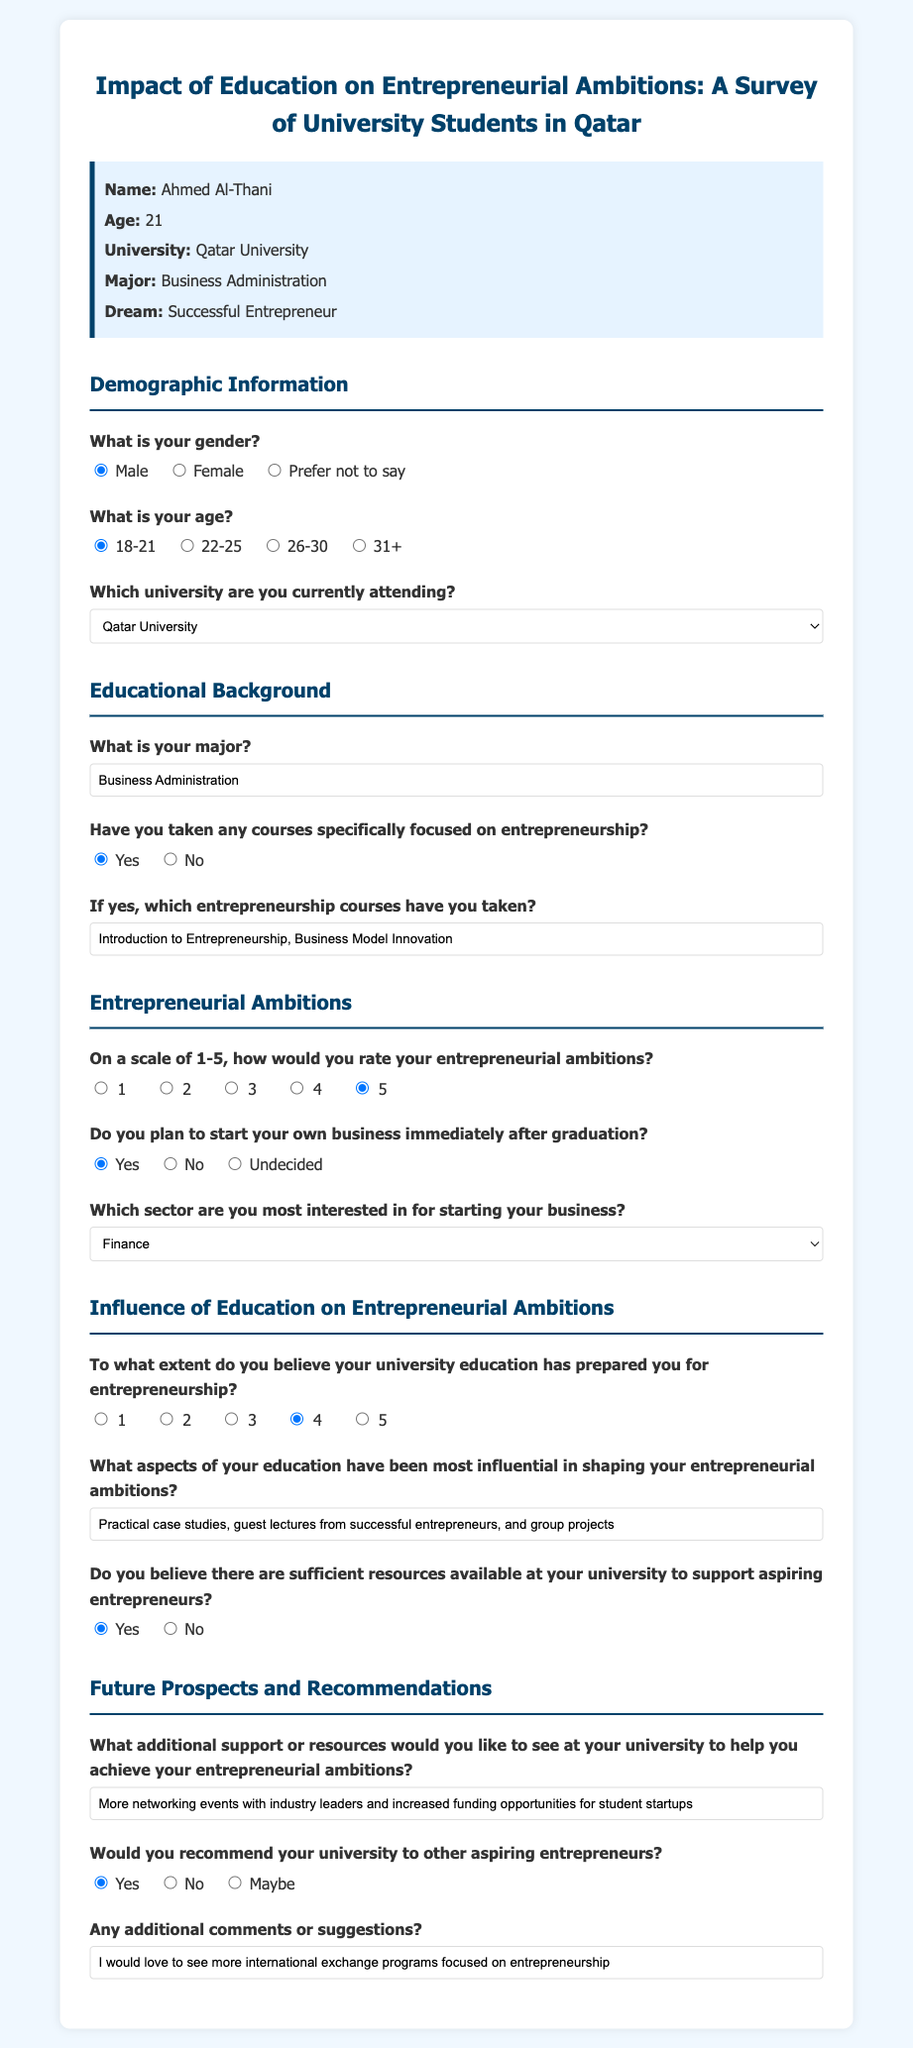What is the name of the student? The student's name is provided in the document under "persona-info."
Answer: Ahmed Al-Thani What is the age range of the respondent? The age range is noted in the demographic section of the survey.
Answer: 18-21 Which university is the respondent attending? The university name is mentioned in the demographic section.
Answer: Qatar University What major is the respondent pursuing? The major is specified in the educational background section.
Answer: Business Administration How does the respondent rate their entrepreneurial ambitions? The rating is given on a scale of 1-5 and is indicated by the selected value in the survey.
Answer: 5 What sector is the respondent most interested in for starting a business? The preferred sector is selected from a dropdown menu in the survey.
Answer: Finance What aspect of education does the respondent find most influential for their entrepreneurial ambitions? This is described in a text input for additional input in the survey.
Answer: Practical case studies, guest lectures from successful entrepreneurs, and group projects Does the respondent believe there are sufficient resources at their university for aspiring entrepreneurs? This response is given as a yes or no choice in the survey.
Answer: Yes What additional support does the respondent desire from their university? This is listed in the open-ended question regarding additional support.
Answer: More networking events with industry leaders and increased funding opportunities for student startups 